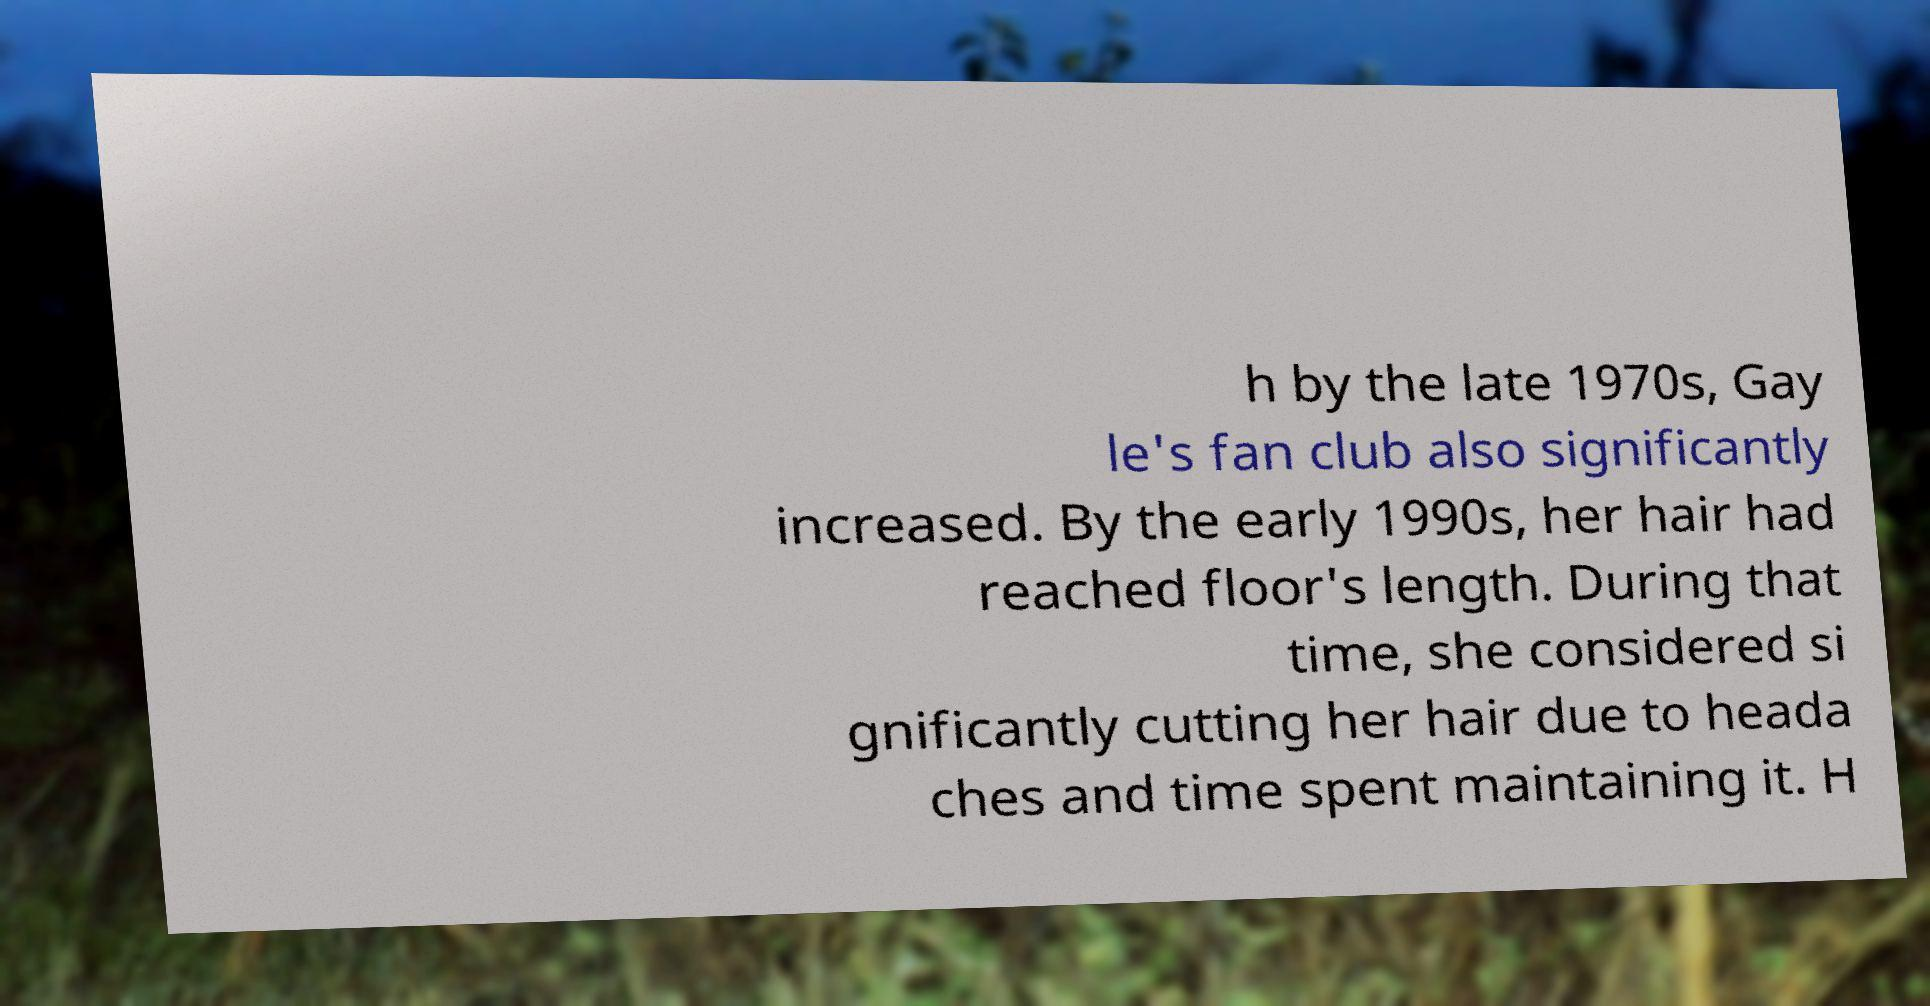Could you extract and type out the text from this image? h by the late 1970s, Gay le's fan club also significantly increased. By the early 1990s, her hair had reached floor's length. During that time, she considered si gnificantly cutting her hair due to heada ches and time spent maintaining it. H 